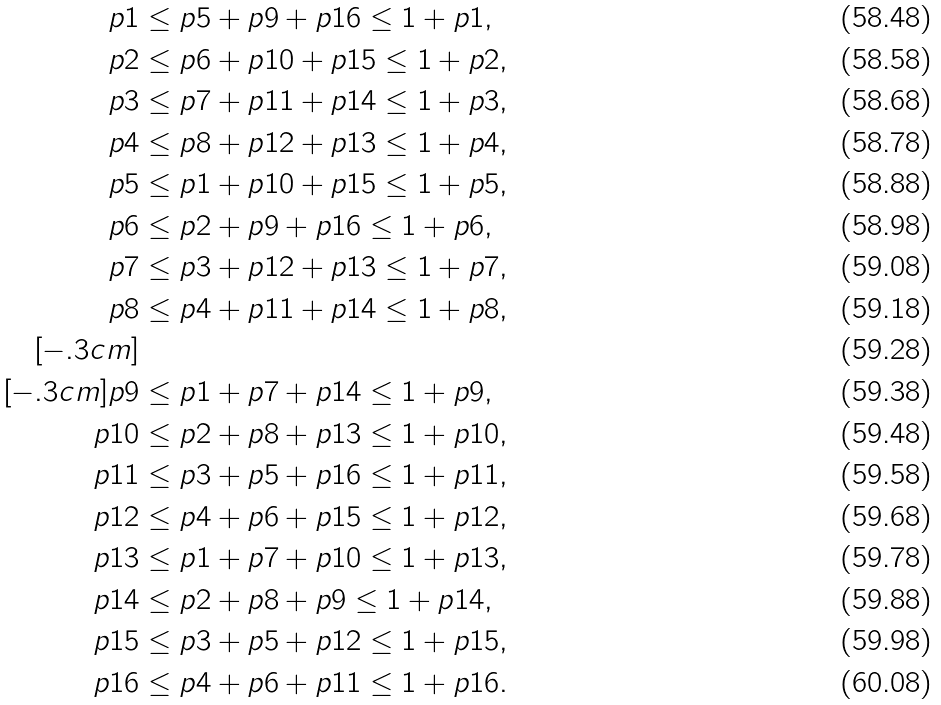Convert formula to latex. <formula><loc_0><loc_0><loc_500><loc_500>p 1 & \leq p 5 + p 9 + p 1 6 \leq 1 + p 1 , \\ p 2 & \leq p 6 + p 1 0 + p 1 5 \leq 1 + p 2 , \\ p 3 & \leq p 7 + p 1 1 + p 1 4 \leq 1 + p 3 , \\ p 4 & \leq p 8 + p 1 2 + p 1 3 \leq 1 + p 4 , \\ p 5 & \leq p 1 + p 1 0 + p 1 5 \leq 1 + p 5 , \\ p 6 & \leq p 2 + p 9 + p 1 6 \leq 1 + p 6 , \\ p 7 & \leq p 3 + p 1 2 + p 1 3 \leq 1 + p 7 , \\ p 8 & \leq p 4 + p 1 1 + p 1 4 \leq 1 + p 8 , \\ [ - . 3 c m ] & \\ [ - . 3 c m ] p 9 & \leq p 1 + p 7 + p 1 4 \leq 1 + p 9 , \\ p 1 0 & \leq p 2 + p 8 + p 1 3 \leq 1 + p 1 0 , \\ p 1 1 & \leq p 3 + p 5 + p 1 6 \leq 1 + p 1 1 , \\ p 1 2 & \leq p 4 + p 6 + p 1 5 \leq 1 + p 1 2 , \\ p 1 3 & \leq p 1 + p 7 + p 1 0 \leq 1 + p 1 3 , \\ p 1 4 & \leq p 2 + p 8 + p 9 \leq 1 + p 1 4 , \\ p 1 5 & \leq p 3 + p 5 + p 1 2 \leq 1 + p 1 5 , \\ p 1 6 & \leq p 4 + p 6 + p 1 1 \leq 1 + p 1 6 .</formula> 